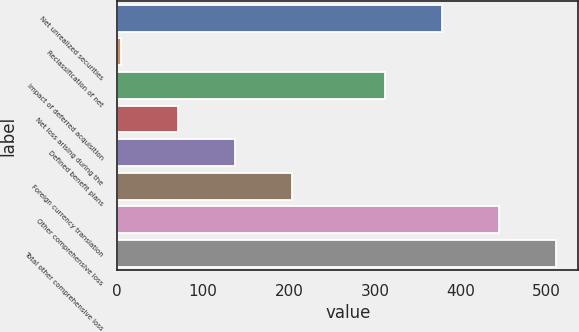Convert chart. <chart><loc_0><loc_0><loc_500><loc_500><bar_chart><fcel>Net unrealized securities<fcel>Reclassification of net<fcel>Impact of deferred acquisition<fcel>Net loss arising during the<fcel>Defined benefit plans<fcel>Foreign currency translation<fcel>Other comprehensive loss<fcel>Total other comprehensive loss<nl><fcel>378.4<fcel>4<fcel>312<fcel>70.4<fcel>136.8<fcel>203.2<fcel>444.8<fcel>511.2<nl></chart> 